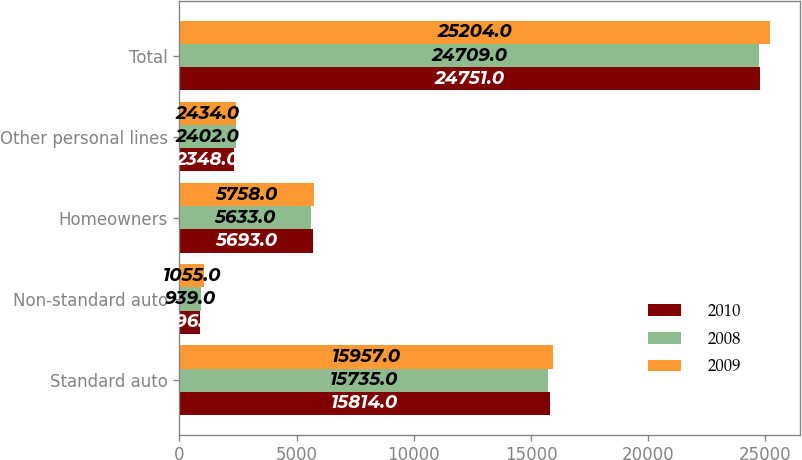<chart> <loc_0><loc_0><loc_500><loc_500><stacked_bar_chart><ecel><fcel>Standard auto<fcel>Non-standard auto<fcel>Homeowners<fcel>Other personal lines<fcel>Total<nl><fcel>2010<fcel>15814<fcel>896<fcel>5693<fcel>2348<fcel>24751<nl><fcel>2008<fcel>15735<fcel>939<fcel>5633<fcel>2402<fcel>24709<nl><fcel>2009<fcel>15957<fcel>1055<fcel>5758<fcel>2434<fcel>25204<nl></chart> 